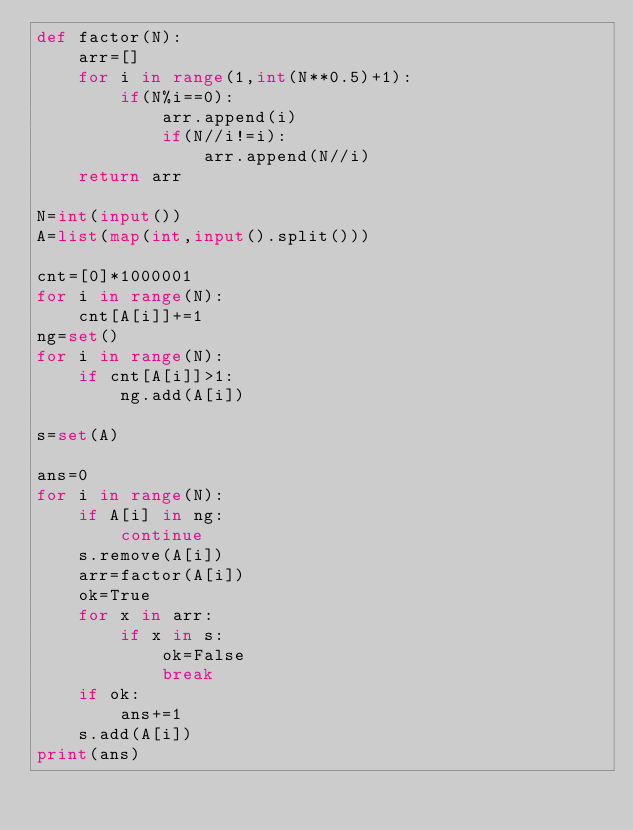Convert code to text. <code><loc_0><loc_0><loc_500><loc_500><_Python_>def factor(N):
    arr=[]
    for i in range(1,int(N**0.5)+1):
        if(N%i==0):
            arr.append(i)
            if(N//i!=i):
                arr.append(N//i)
    return arr

N=int(input())
A=list(map(int,input().split()))

cnt=[0]*1000001
for i in range(N):
    cnt[A[i]]+=1
ng=set()
for i in range(N):
    if cnt[A[i]]>1:
        ng.add(A[i])

s=set(A)

ans=0
for i in range(N):
    if A[i] in ng:
        continue
    s.remove(A[i])
    arr=factor(A[i])
    ok=True
    for x in arr:
        if x in s:
            ok=False
            break
    if ok:
        ans+=1
    s.add(A[i])
print(ans)</code> 